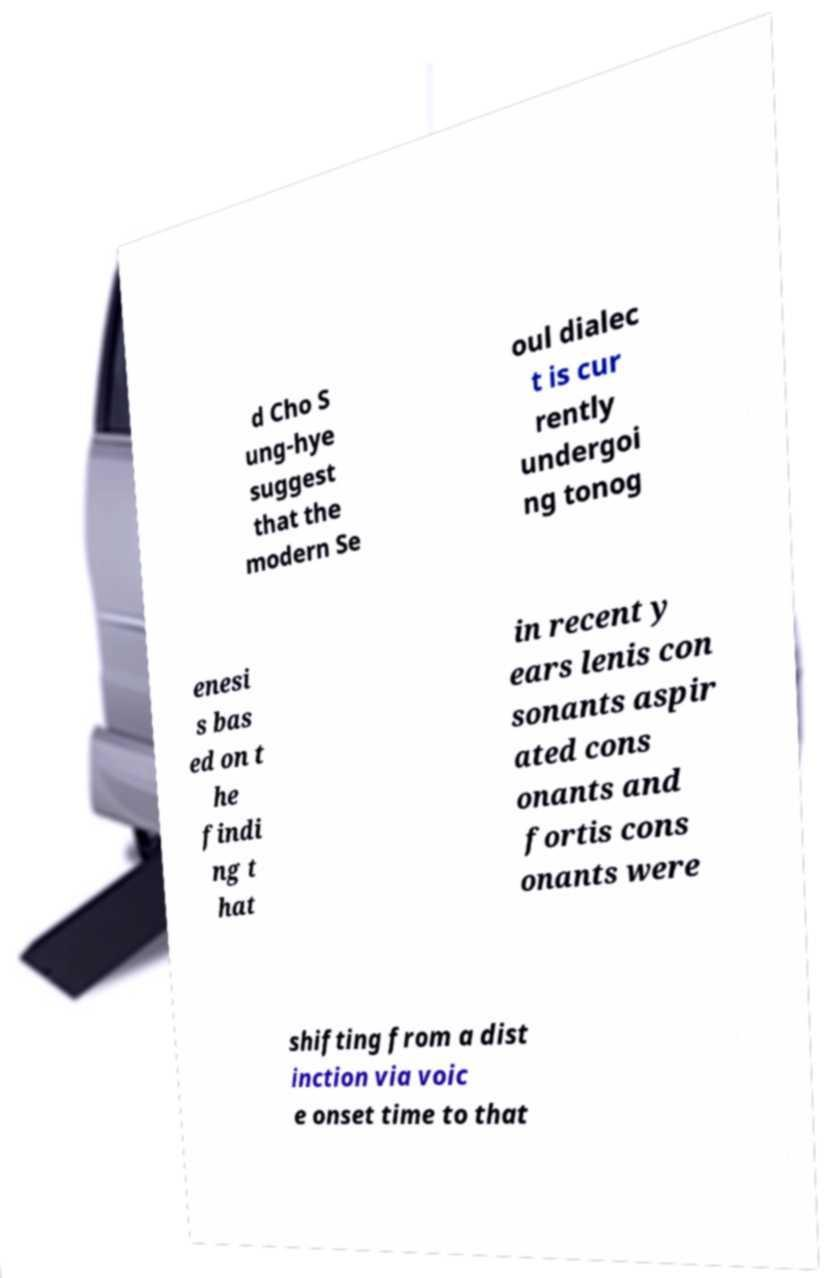What messages or text are displayed in this image? I need them in a readable, typed format. d Cho S ung-hye suggest that the modern Se oul dialec t is cur rently undergoi ng tonog enesi s bas ed on t he findi ng t hat in recent y ears lenis con sonants aspir ated cons onants and fortis cons onants were shifting from a dist inction via voic e onset time to that 